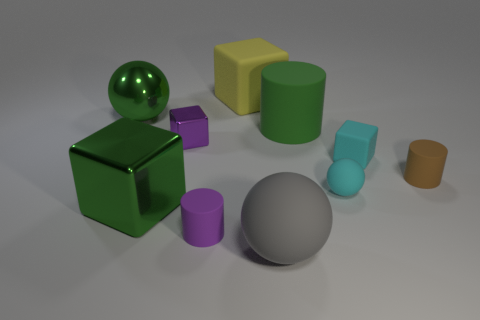What size is the other gray ball that is made of the same material as the tiny ball?
Your answer should be compact. Large. The small object that is behind the brown matte cylinder and on the right side of the small matte ball is what color?
Your answer should be compact. Cyan. There is a large shiny thing that is in front of the big metal sphere; is it the same shape as the purple thing that is in front of the purple shiny object?
Your response must be concise. No. There is a green object in front of the purple block; what material is it?
Give a very brief answer. Metal. What is the size of the matte cylinder that is the same color as the tiny shiny thing?
Make the answer very short. Small. What number of objects are either balls left of the large gray thing or brown metal blocks?
Provide a short and direct response. 1. Are there an equal number of big yellow rubber things that are in front of the small brown rubber cylinder and big balls?
Keep it short and to the point. No. Is the size of the brown rubber cylinder the same as the cyan sphere?
Your answer should be very brief. Yes. What is the color of the shiny cube that is the same size as the gray rubber object?
Your response must be concise. Green. There is a yellow block; is its size the same as the cyan thing that is in front of the tiny cyan rubber cube?
Ensure brevity in your answer.  No. 